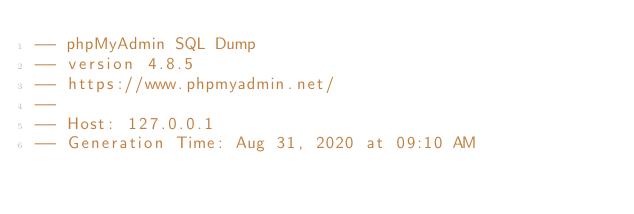<code> <loc_0><loc_0><loc_500><loc_500><_SQL_>-- phpMyAdmin SQL Dump
-- version 4.8.5
-- https://www.phpmyadmin.net/
--
-- Host: 127.0.0.1
-- Generation Time: Aug 31, 2020 at 09:10 AM</code> 